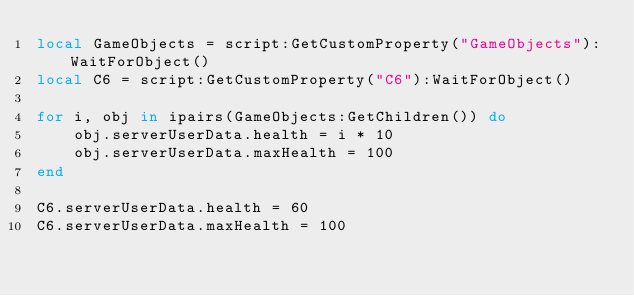<code> <loc_0><loc_0><loc_500><loc_500><_Lua_>local GameObjects = script:GetCustomProperty("GameObjects"):WaitForObject()
local C6 = script:GetCustomProperty("C6"):WaitForObject()

for i, obj in ipairs(GameObjects:GetChildren()) do
    obj.serverUserData.health = i * 10
    obj.serverUserData.maxHealth = 100
end

C6.serverUserData.health = 60
C6.serverUserData.maxHealth = 100</code> 